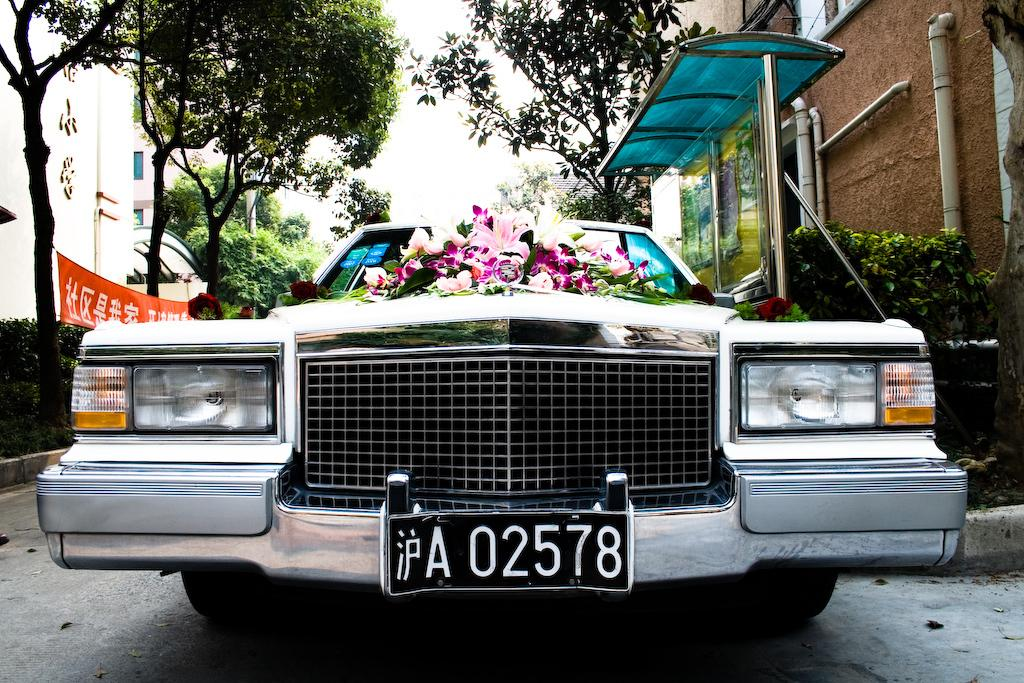What is the main subject of the image? The main subject of the image is a car. What is the car doing in the image? The car is parked in the image. What is placed on the bonnet of the car? There are flowers placed on the bonnet of the car. What can be seen in the background of the image? There are trees and buildings in the background of the image. Can you hear the sound of rain in the image? There is no mention of rain or any sound in the image, so it cannot be determined if rain is present or if it can be heard. 